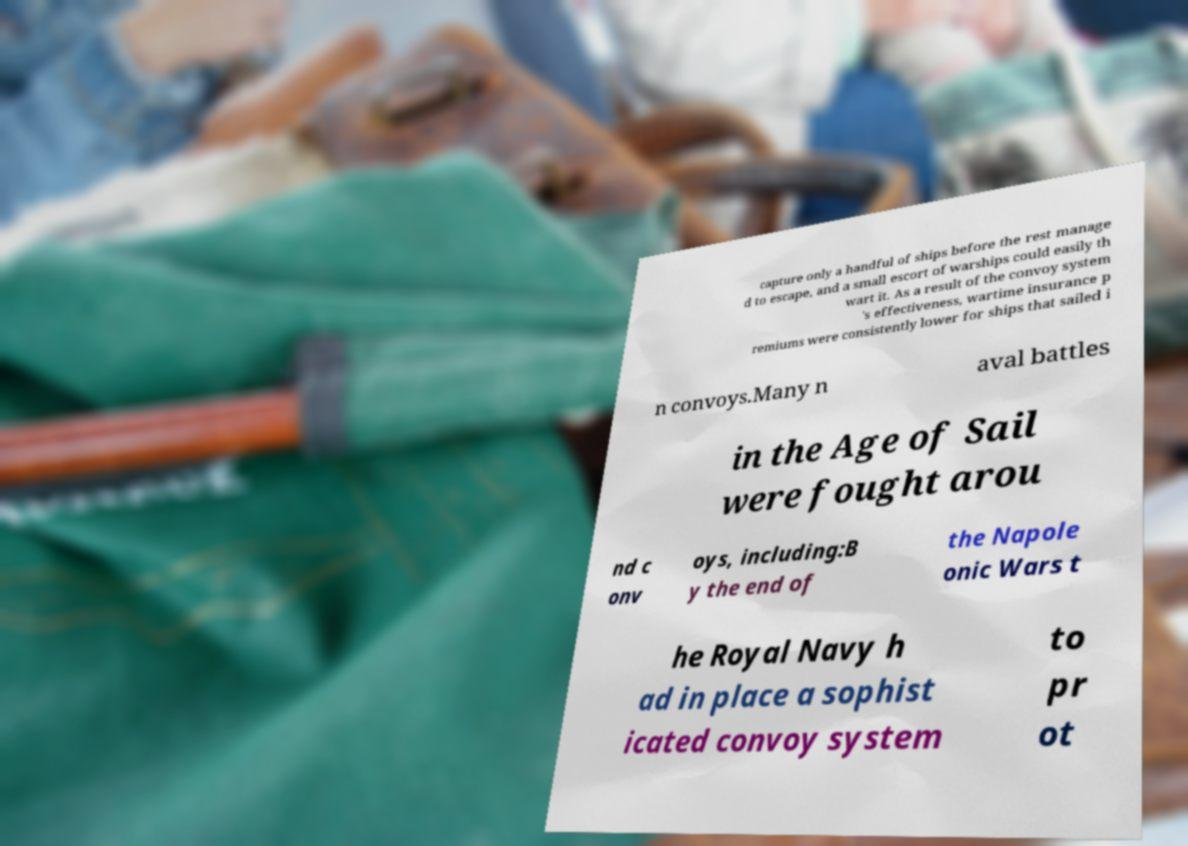There's text embedded in this image that I need extracted. Can you transcribe it verbatim? capture only a handful of ships before the rest manage d to escape, and a small escort of warships could easily th wart it. As a result of the convoy system 's effectiveness, wartime insurance p remiums were consistently lower for ships that sailed i n convoys.Many n aval battles in the Age of Sail were fought arou nd c onv oys, including:B y the end of the Napole onic Wars t he Royal Navy h ad in place a sophist icated convoy system to pr ot 